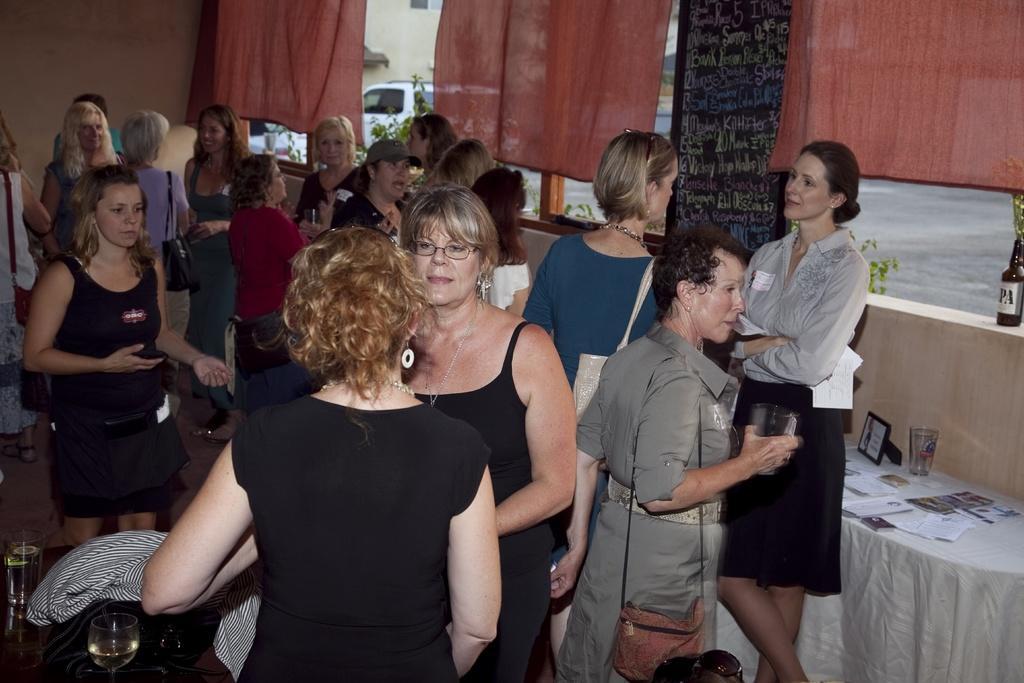Could you give a brief overview of what you see in this image? In this image we can see few people standing in a room, a person is holding a glass and a person is holding papers, there are glasses with drink and few objects on a table and there is another table covered with cloth and there are few papers, a glass and a photo frame on the table and there is a bottle on the wall, curtains to the window and a blackboard with text and through the window we can see a car on the road, few plants and a building. 